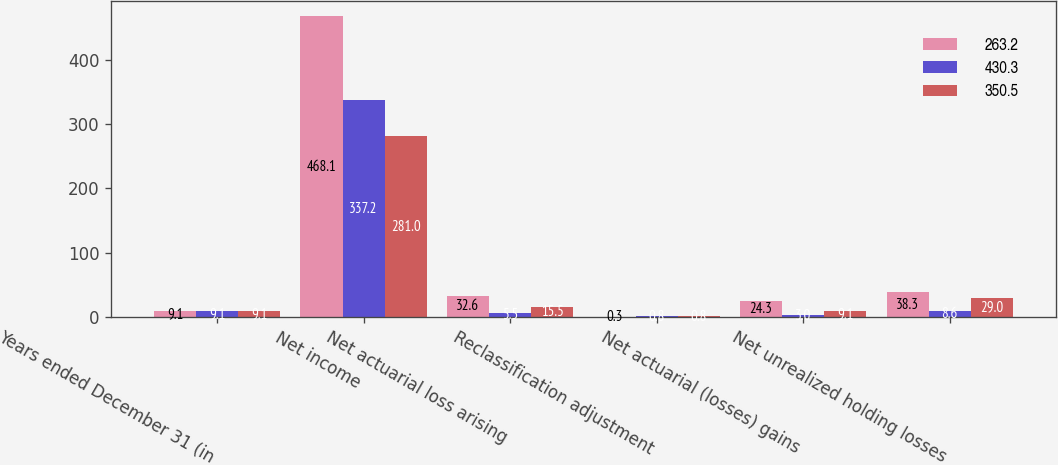Convert chart to OTSL. <chart><loc_0><loc_0><loc_500><loc_500><stacked_bar_chart><ecel><fcel>Years ended December 31 (in<fcel>Net income<fcel>Net actuarial loss arising<fcel>Reclassification adjustment<fcel>Net actuarial (losses) gains<fcel>Net unrealized holding losses<nl><fcel>263.2<fcel>9.1<fcel>468.1<fcel>32.6<fcel>0.3<fcel>24.3<fcel>38.3<nl><fcel>430.3<fcel>9.1<fcel>337.2<fcel>5.5<fcel>0.8<fcel>3<fcel>8.6<nl><fcel>350.5<fcel>9.1<fcel>281<fcel>15.5<fcel>0.8<fcel>9.1<fcel>29<nl></chart> 